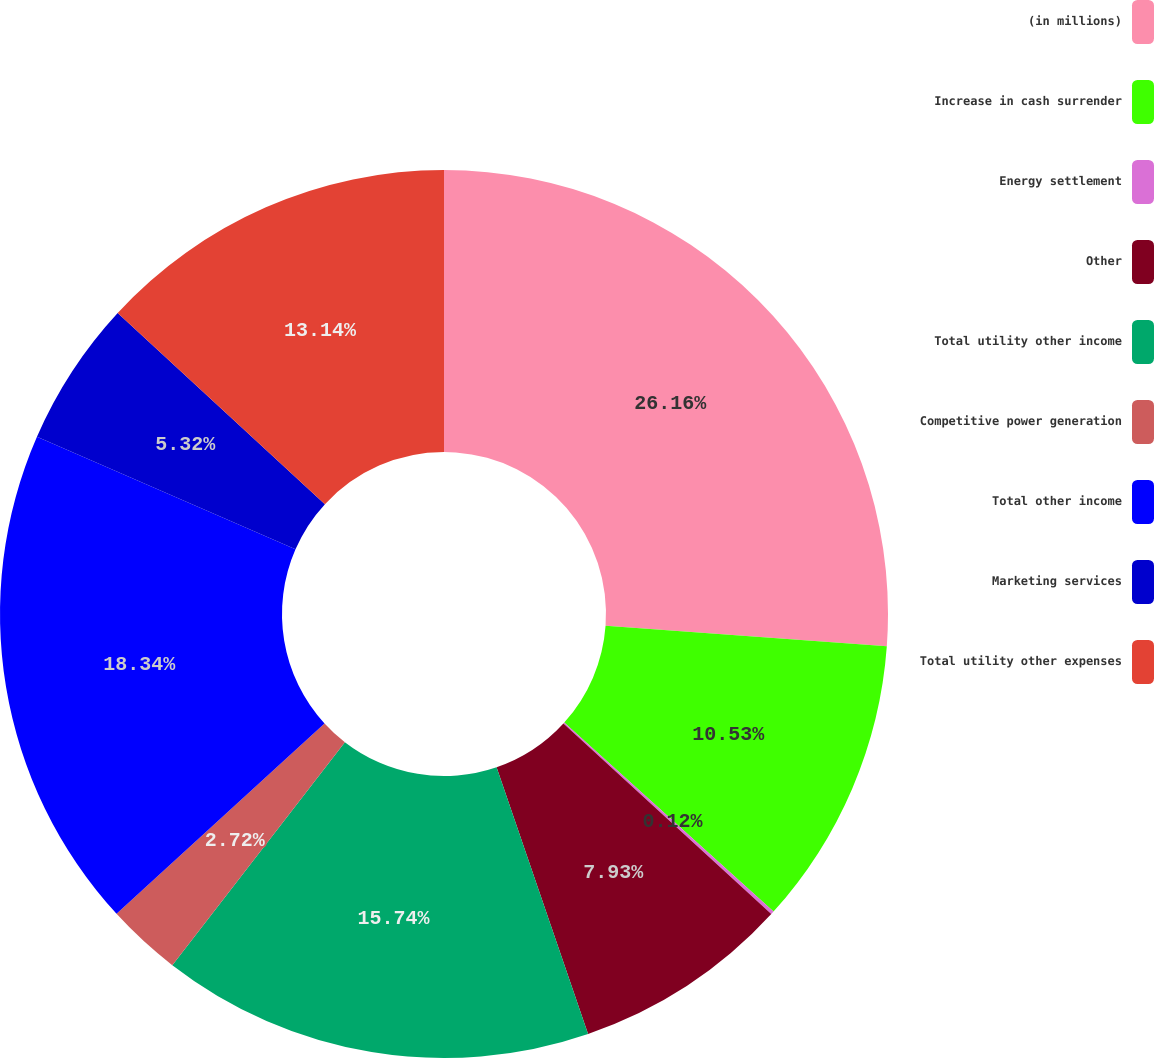<chart> <loc_0><loc_0><loc_500><loc_500><pie_chart><fcel>(in millions)<fcel>Increase in cash surrender<fcel>Energy settlement<fcel>Other<fcel>Total utility other income<fcel>Competitive power generation<fcel>Total other income<fcel>Marketing services<fcel>Total utility other expenses<nl><fcel>26.16%<fcel>10.53%<fcel>0.12%<fcel>7.93%<fcel>15.74%<fcel>2.72%<fcel>18.34%<fcel>5.32%<fcel>13.14%<nl></chart> 